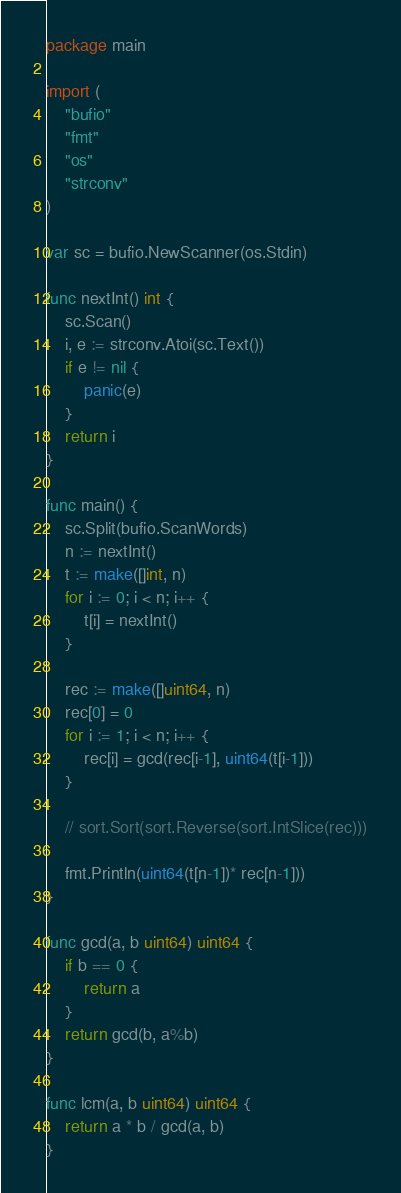Convert code to text. <code><loc_0><loc_0><loc_500><loc_500><_Go_>package main

import (
	"bufio"
	"fmt"
	"os"
	"strconv"
)

var sc = bufio.NewScanner(os.Stdin)

func nextInt() int {
	sc.Scan()
	i, e := strconv.Atoi(sc.Text())
	if e != nil {
		panic(e)
	}
	return i
}

func main() {
	sc.Split(bufio.ScanWords)
	n := nextInt()
	t := make([]int, n)
	for i := 0; i < n; i++ {
		t[i] = nextInt()
	}

	rec := make([]uint64, n)
	rec[0] = 0
	for i := 1; i < n; i++ {
		rec[i] = gcd(rec[i-1], uint64(t[i-1]))
	}

	// sort.Sort(sort.Reverse(sort.IntSlice(rec)))

	fmt.Println(uint64(t[n-1])* rec[n-1]))
}

func gcd(a, b uint64) uint64 {
	if b == 0 {
		return a
	}
	return gcd(b, a%b)
}

func lcm(a, b uint64) uint64 {
	return a * b / gcd(a, b)
}
</code> 